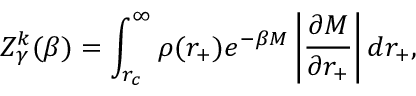Convert formula to latex. <formula><loc_0><loc_0><loc_500><loc_500>Z _ { \gamma } ^ { k } ( \beta ) = \int _ { r _ { c } } ^ { \infty } \rho ( r _ { + } ) e ^ { - \beta M } \left | \frac { \partial M } { \partial r _ { + } } \right | d r _ { + } ,</formula> 